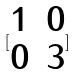<formula> <loc_0><loc_0><loc_500><loc_500>[ \begin{matrix} 1 & 0 \\ 0 & 3 \end{matrix} ]</formula> 